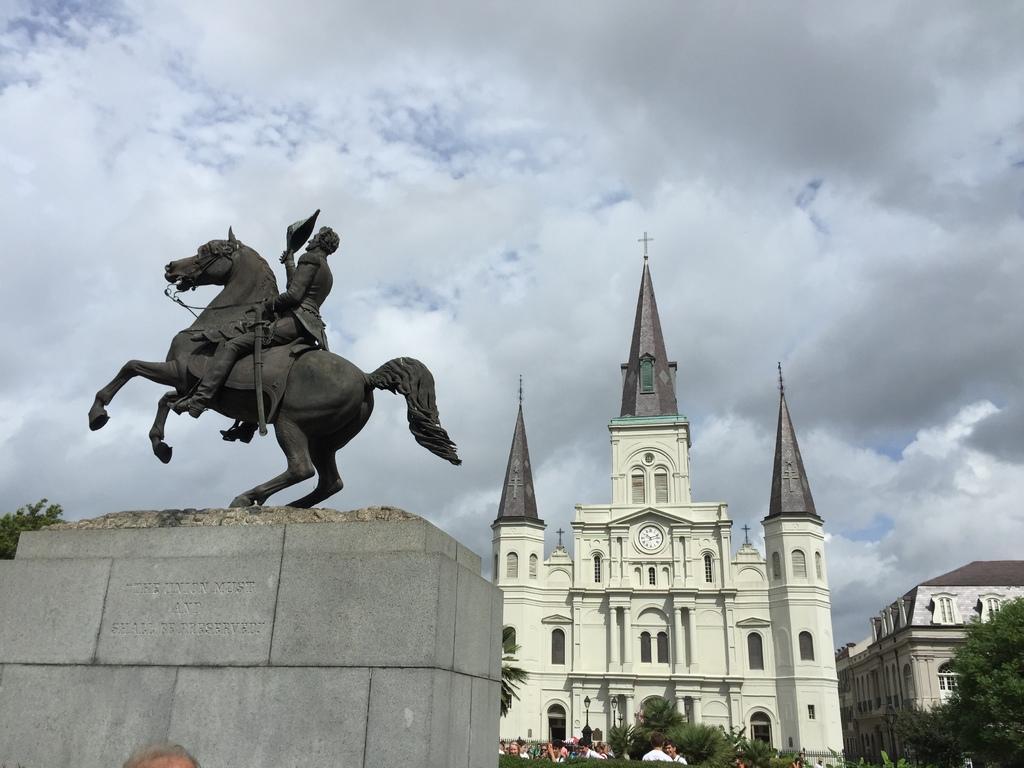How would you summarize this image in a sentence or two? In this picture we can see a statue on an object. Behind the statue, there are buildings, people and trees. At the top of the image, there is the cloudy sky. 